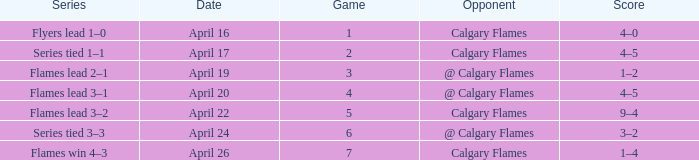Which Series has an Opponent of calgary flames, and a Score of 9–4? Flames lead 3–2. 